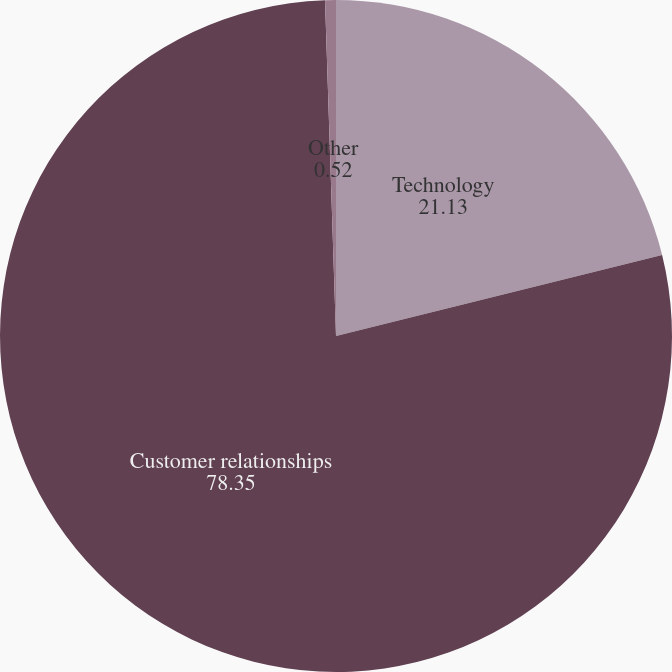Convert chart. <chart><loc_0><loc_0><loc_500><loc_500><pie_chart><fcel>Technology<fcel>Customer relationships<fcel>Other<nl><fcel>21.13%<fcel>78.35%<fcel>0.52%<nl></chart> 